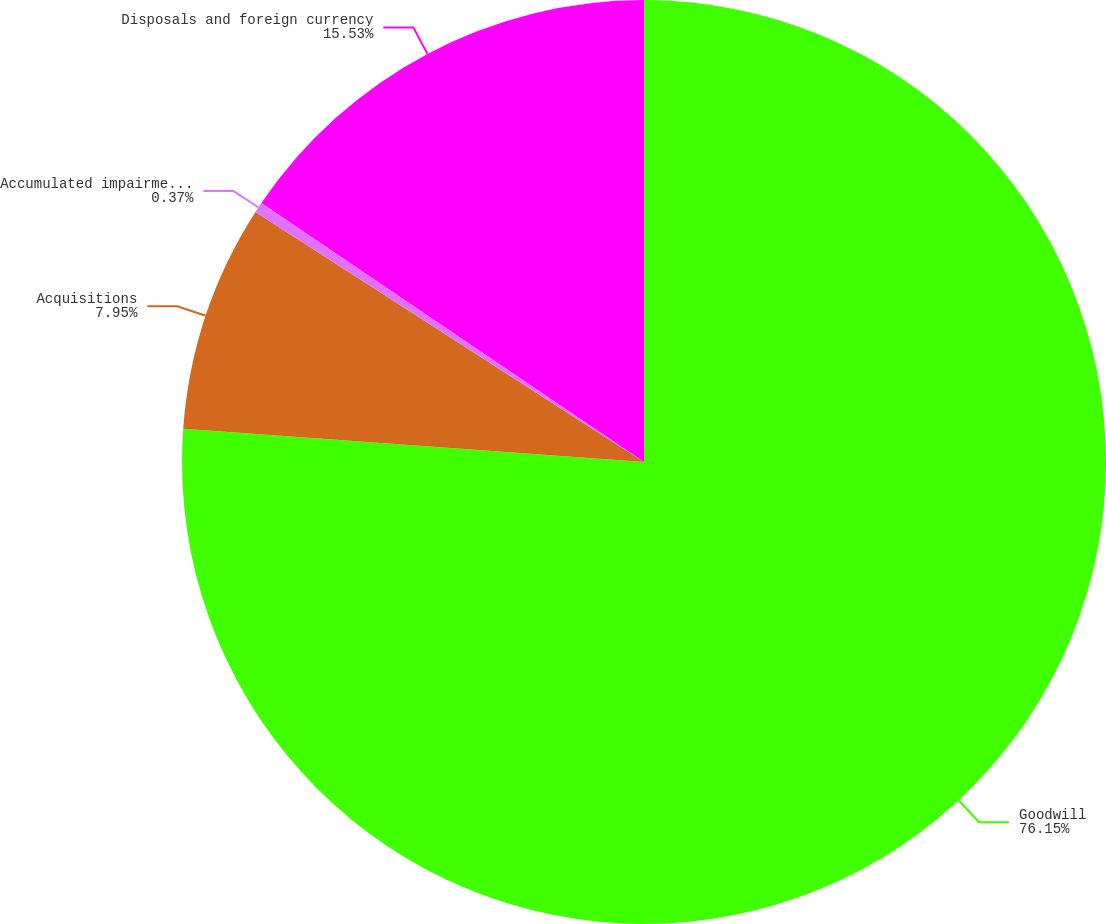<chart> <loc_0><loc_0><loc_500><loc_500><pie_chart><fcel>Goodwill<fcel>Acquisitions<fcel>Accumulated impairment losses<fcel>Disposals and foreign currency<nl><fcel>76.15%<fcel>7.95%<fcel>0.37%<fcel>15.53%<nl></chart> 